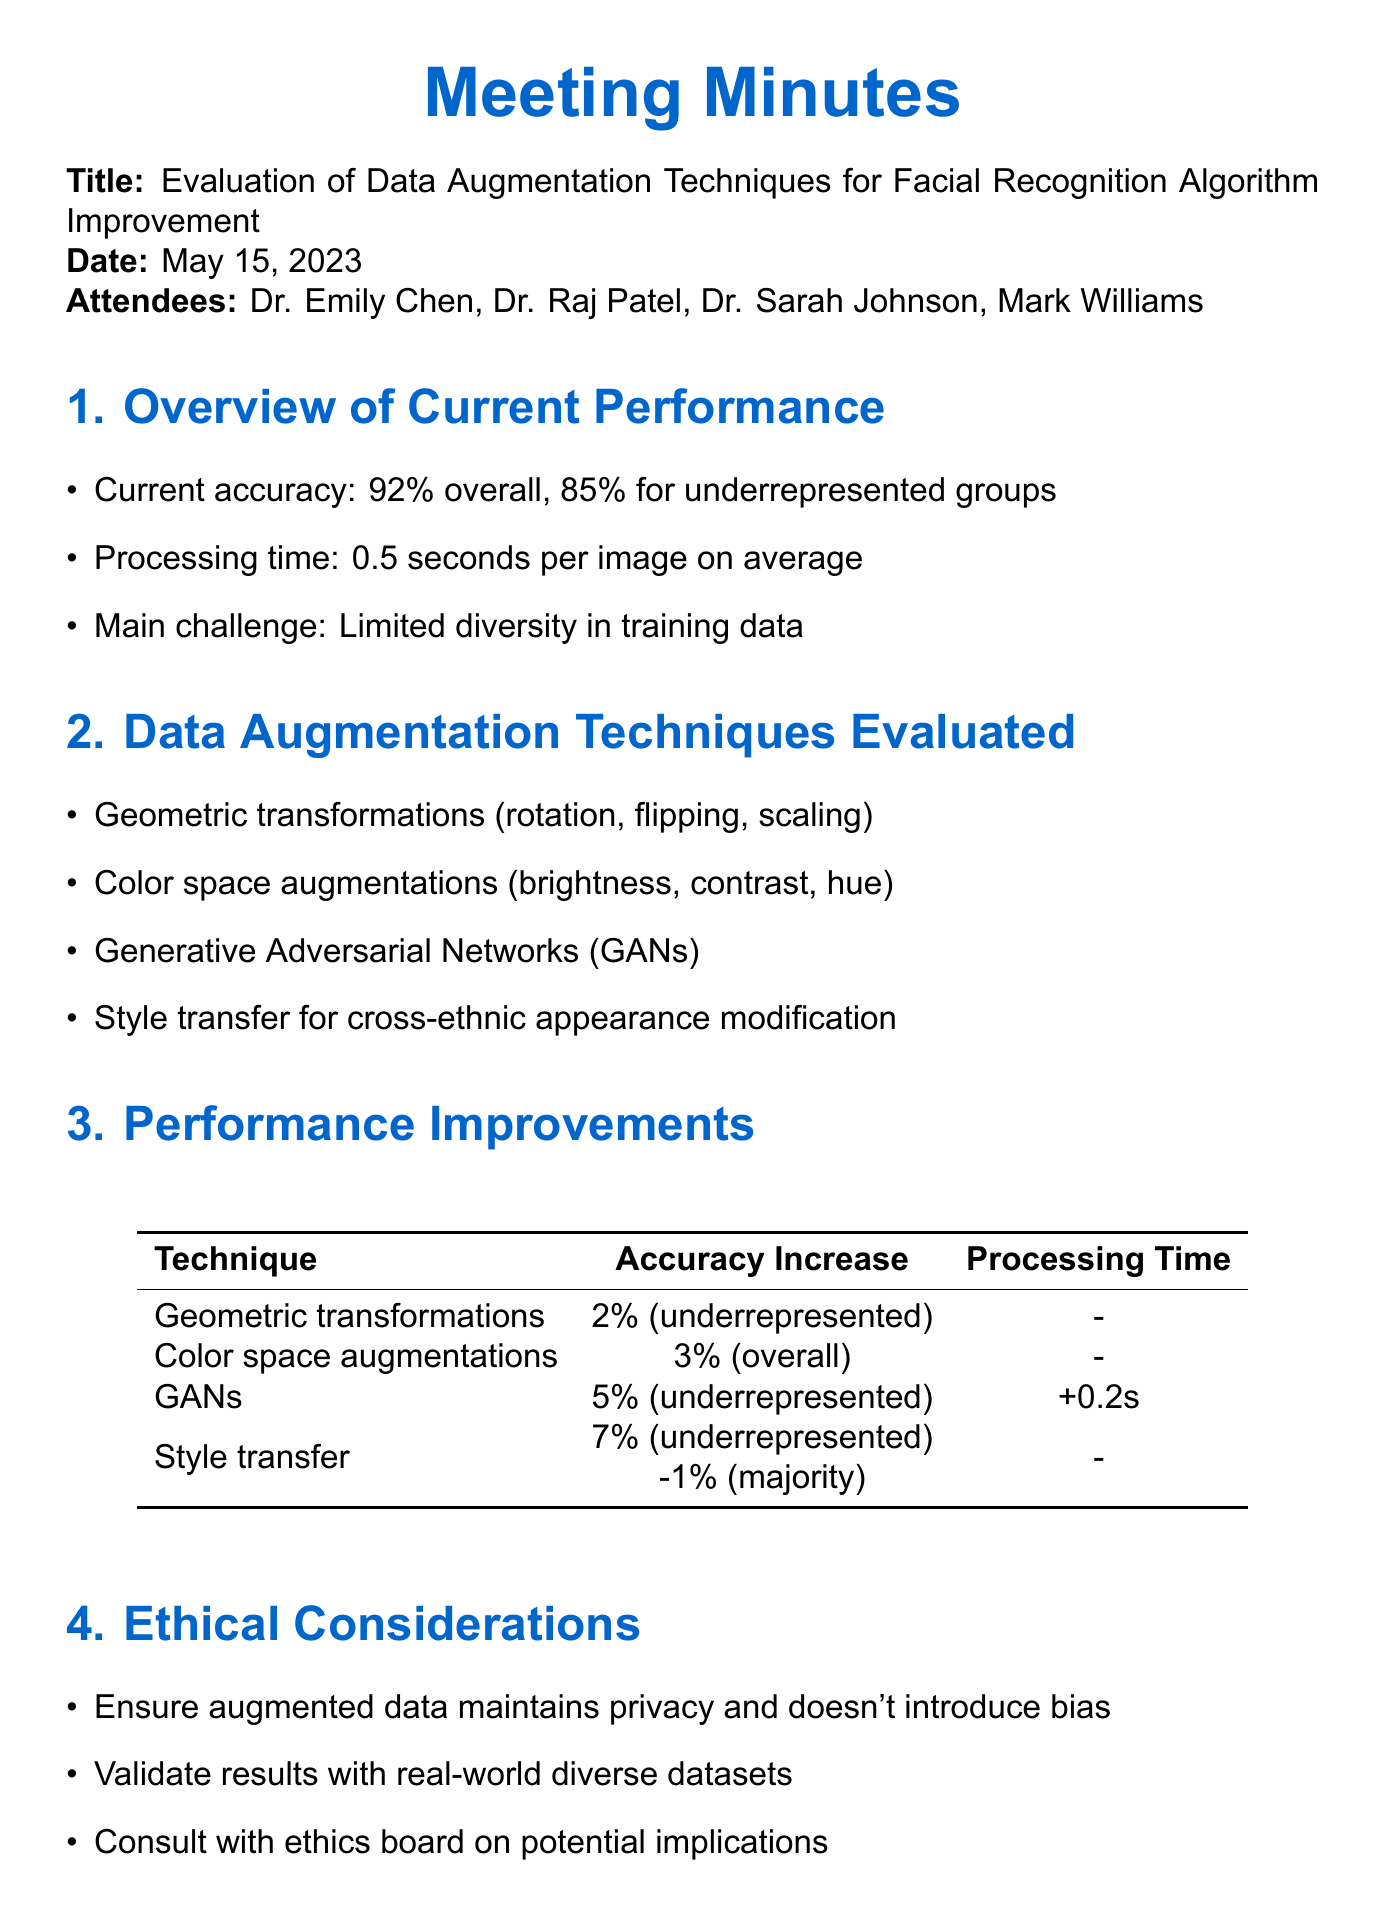What is the overall accuracy of the facial recognition algorithm? The overall accuracy of the facial recognition algorithm is mentioned in the overview section as 92%.
Answer: 92% What percentage accuracy improvement did color space augmentations achieve? The accuracy improvement for color space augmentations is provided in the performance improvements section as 3%.
Answer: 3% How much longer does the processing time increase with GANs? The document states that using GANs increases the processing time by 0.2 seconds, as noted in the performance improvements section.
Answer: 0.2 seconds Which augmentation technique provided the highest accuracy increase for underrepresented groups? The performance improvements section indicates that style transfer provided the highest accuracy increase of 7% for underrepresented groups.
Answer: 7% What is the main challenge faced by the current facial recognition algorithm? The main challenge noted in the overview section is limited diversity in training data.
Answer: Limited diversity in training data What should be validated with real-world diverse datasets? The document mentions that results should be validated with real-world diverse datasets in the ethical considerations section.
Answer: Results What is the date of the meeting? The date of the meeting is explicitly stated in the document as May 15, 2023.
Answer: May 15, 2023 Who is the Lead Computer Scientist attending the meeting? The document lists Dr. Emily Chen as the Lead Computer Scientist among the attendees.
Answer: Dr. Emily Chen What are the next steps discussed after the evaluation? The next steps include implementing a combination of GANs and style transfer techniques as noted in the next steps section.
Answer: Implement combination of GANs and style transfer techniques 